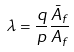Convert formula to latex. <formula><loc_0><loc_0><loc_500><loc_500>\lambda = \frac { q } { p } \frac { \bar { A } _ { f } } { A _ { f } }</formula> 